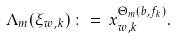<formula> <loc_0><loc_0><loc_500><loc_500>\Lambda _ { m } ( \xi _ { w , k } ) \, \colon = \, x _ { w , k } ^ { \Theta _ { m } ( { b } , { f } _ { k } ) } .</formula> 